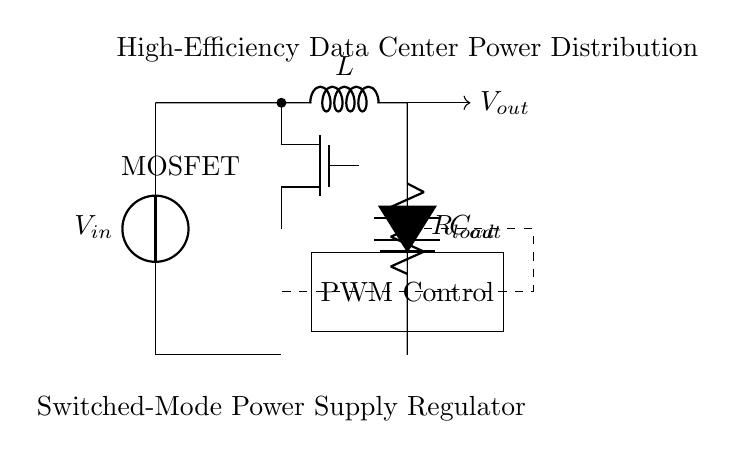What is the type of regulator shown in the circuit? The circuit diagram depicts a switched-mode power supply regulator, which is indicated by the components and connections specific to this type of power supply design.
Answer: Switched-mode power supply What component is used as the switch in this regulator? The MOSFET is used as the switch in this circuit. It is explicitly labeled in the diagram and plays a crucial role in controlling the flow of current.
Answer: MOSFET What is the purpose of the inductor in this circuit? The inductor, labeled as L, is essential for energy storage and smoothing the current flow in switched-mode power supplies, allowing the circuit to convert input voltage to a desired output efficiently.
Answer: Energy storage What does the PWM control component do? The PWM control component adjusts the duty cycle of the switch, allowing for regulation of the output voltage by controlling the on/off time of the MOSFET, which is vital for maintaining stable output under varying loads.
Answer: Regulates output voltage What is the relationship between the output capacitor and the load resistance in this regulator? The output capacitor, labeled as C, works alongside the load resistor, labeled as R load, to filter the output voltage and smooth out any ripples, ensuring a stable supply to the load despite variations in current demand.
Answer: Smoothing ripples What are the input and output voltage designations in the circuit? The input voltage is designated as Vin, while the output voltage is labeled as Vout, clearly shown in the diagram, representing the voltages measured at the respective points in the circuit.
Answer: Vin and Vout 